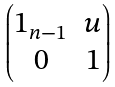Convert formula to latex. <formula><loc_0><loc_0><loc_500><loc_500>\begin{pmatrix} 1 _ { n - 1 } & u \\ 0 & 1 \\ \end{pmatrix}</formula> 